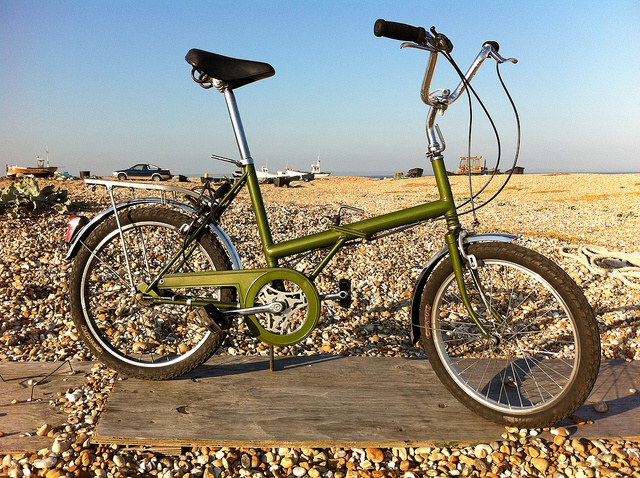Describe the objects in this image and their specific colors. I can see bicycle in gray, black, olive, and maroon tones, car in gray, black, navy, and darkgray tones, boat in gray, black, maroon, brown, and tan tones, and boat in gray, ivory, darkgray, and tan tones in this image. 